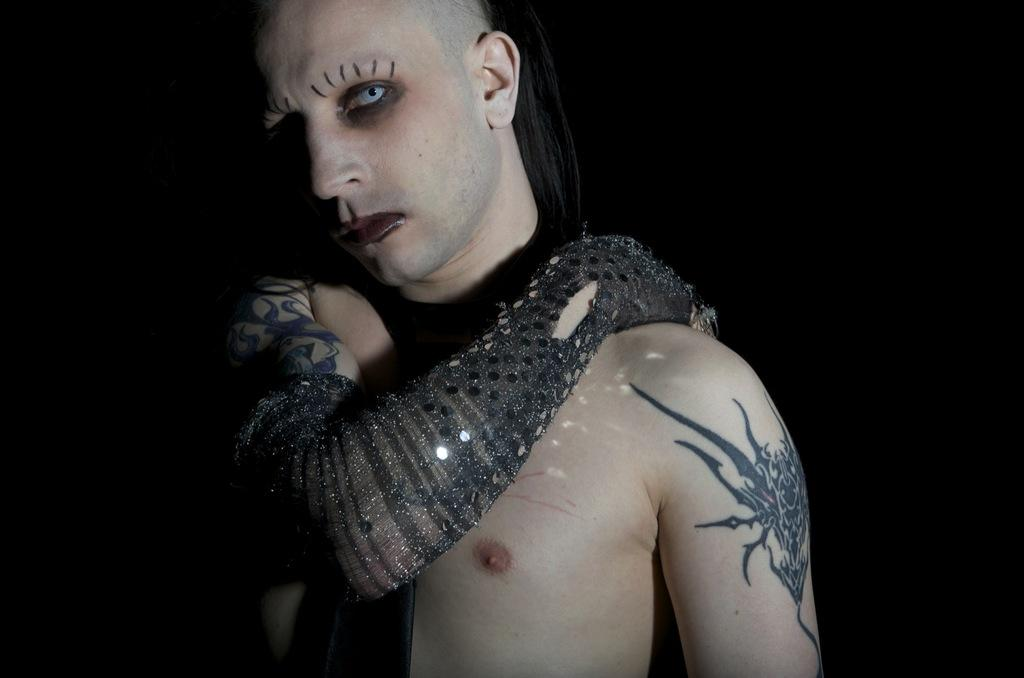What is present in the image? There is a person in the image. Can you describe any distinguishing features of the person? The person has tattoos. What type of dog is sitting next to the person in the image? There is no dog present in the image; only the person with tattoos is visible. 